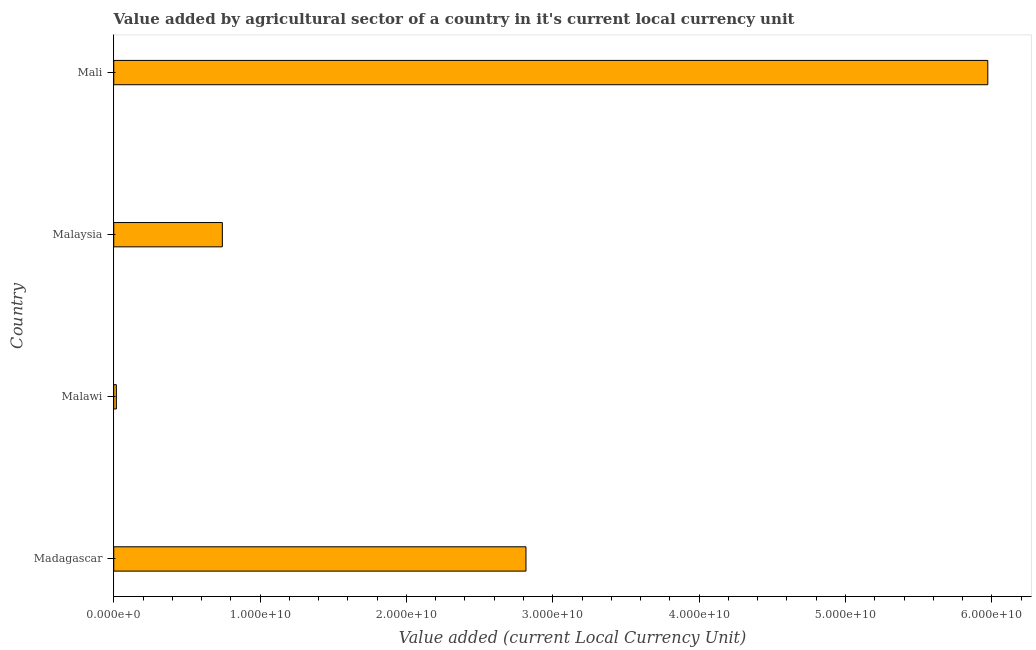Does the graph contain any zero values?
Your answer should be compact. No. What is the title of the graph?
Your answer should be very brief. Value added by agricultural sector of a country in it's current local currency unit. What is the label or title of the X-axis?
Make the answer very short. Value added (current Local Currency Unit). What is the label or title of the Y-axis?
Offer a very short reply. Country. What is the value added by agriculture sector in Malaysia?
Offer a very short reply. 7.42e+09. Across all countries, what is the maximum value added by agriculture sector?
Provide a short and direct response. 5.97e+1. Across all countries, what is the minimum value added by agriculture sector?
Your response must be concise. 1.78e+08. In which country was the value added by agriculture sector maximum?
Provide a succinct answer. Mali. In which country was the value added by agriculture sector minimum?
Provide a short and direct response. Malawi. What is the sum of the value added by agriculture sector?
Give a very brief answer. 9.55e+1. What is the difference between the value added by agriculture sector in Malaysia and Mali?
Ensure brevity in your answer.  -5.23e+1. What is the average value added by agriculture sector per country?
Provide a succinct answer. 2.39e+1. What is the median value added by agriculture sector?
Ensure brevity in your answer.  1.78e+1. What is the ratio of the value added by agriculture sector in Malawi to that in Malaysia?
Your answer should be very brief. 0.02. Is the value added by agriculture sector in Madagascar less than that in Malaysia?
Offer a terse response. No. What is the difference between the highest and the second highest value added by agriculture sector?
Give a very brief answer. 3.16e+1. Is the sum of the value added by agriculture sector in Madagascar and Mali greater than the maximum value added by agriculture sector across all countries?
Provide a succinct answer. Yes. What is the difference between the highest and the lowest value added by agriculture sector?
Ensure brevity in your answer.  5.95e+1. In how many countries, is the value added by agriculture sector greater than the average value added by agriculture sector taken over all countries?
Offer a very short reply. 2. Are the values on the major ticks of X-axis written in scientific E-notation?
Offer a terse response. Yes. What is the Value added (current Local Currency Unit) in Madagascar?
Ensure brevity in your answer.  2.82e+1. What is the Value added (current Local Currency Unit) in Malawi?
Provide a succinct answer. 1.78e+08. What is the Value added (current Local Currency Unit) of Malaysia?
Keep it short and to the point. 7.42e+09. What is the Value added (current Local Currency Unit) of Mali?
Offer a terse response. 5.97e+1. What is the difference between the Value added (current Local Currency Unit) in Madagascar and Malawi?
Your response must be concise. 2.80e+1. What is the difference between the Value added (current Local Currency Unit) in Madagascar and Malaysia?
Offer a very short reply. 2.07e+1. What is the difference between the Value added (current Local Currency Unit) in Madagascar and Mali?
Ensure brevity in your answer.  -3.16e+1. What is the difference between the Value added (current Local Currency Unit) in Malawi and Malaysia?
Keep it short and to the point. -7.24e+09. What is the difference between the Value added (current Local Currency Unit) in Malawi and Mali?
Provide a succinct answer. -5.95e+1. What is the difference between the Value added (current Local Currency Unit) in Malaysia and Mali?
Offer a very short reply. -5.23e+1. What is the ratio of the Value added (current Local Currency Unit) in Madagascar to that in Malawi?
Give a very brief answer. 157.9. What is the ratio of the Value added (current Local Currency Unit) in Madagascar to that in Malaysia?
Offer a terse response. 3.8. What is the ratio of the Value added (current Local Currency Unit) in Madagascar to that in Mali?
Offer a very short reply. 0.47. What is the ratio of the Value added (current Local Currency Unit) in Malawi to that in Malaysia?
Make the answer very short. 0.02. What is the ratio of the Value added (current Local Currency Unit) in Malawi to that in Mali?
Provide a succinct answer. 0. What is the ratio of the Value added (current Local Currency Unit) in Malaysia to that in Mali?
Provide a succinct answer. 0.12. 